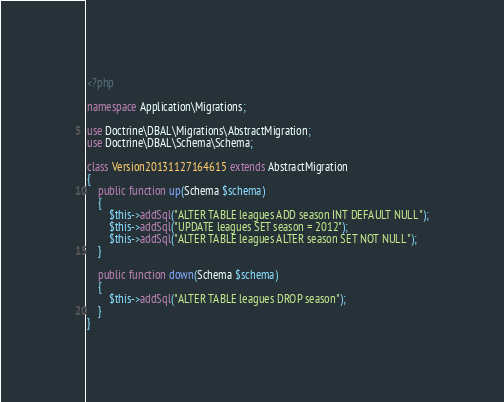Convert code to text. <code><loc_0><loc_0><loc_500><loc_500><_PHP_><?php

namespace Application\Migrations;

use Doctrine\DBAL\Migrations\AbstractMigration;
use Doctrine\DBAL\Schema\Schema;

class Version20131127164615 extends AbstractMigration
{
    public function up(Schema $schema)
    {
        $this->addSql("ALTER TABLE leagues ADD season INT DEFAULT NULL");
        $this->addSql("UPDATE leagues SET season = 2012");
        $this->addSql("ALTER TABLE leagues ALTER season SET NOT NULL");
    }

    public function down(Schema $schema)
    {
        $this->addSql("ALTER TABLE leagues DROP season");
    }
}
</code> 